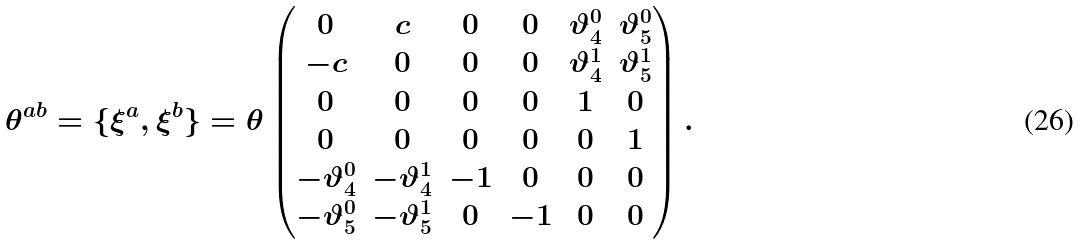<formula> <loc_0><loc_0><loc_500><loc_500>\theta ^ { a b } = \{ \xi ^ { a } , \xi ^ { b } \} = \theta \begin{pmatrix} 0 & c & 0 & 0 & \vartheta ^ { 0 } _ { 4 } & \vartheta ^ { 0 } _ { 5 } \\ - c & 0 & 0 & 0 & \vartheta ^ { 1 } _ { 4 } & \vartheta ^ { 1 } _ { 5 } \\ 0 & 0 & 0 & 0 & 1 & 0 \\ 0 & 0 & 0 & 0 & 0 & 1 \\ - \vartheta ^ { 0 } _ { 4 } & - \vartheta ^ { 1 } _ { 4 } & - 1 & 0 & 0 & 0 \\ - \vartheta ^ { 0 } _ { 5 } & - \vartheta ^ { 1 } _ { 5 } & 0 & - 1 & 0 & 0 \end{pmatrix} .</formula> 